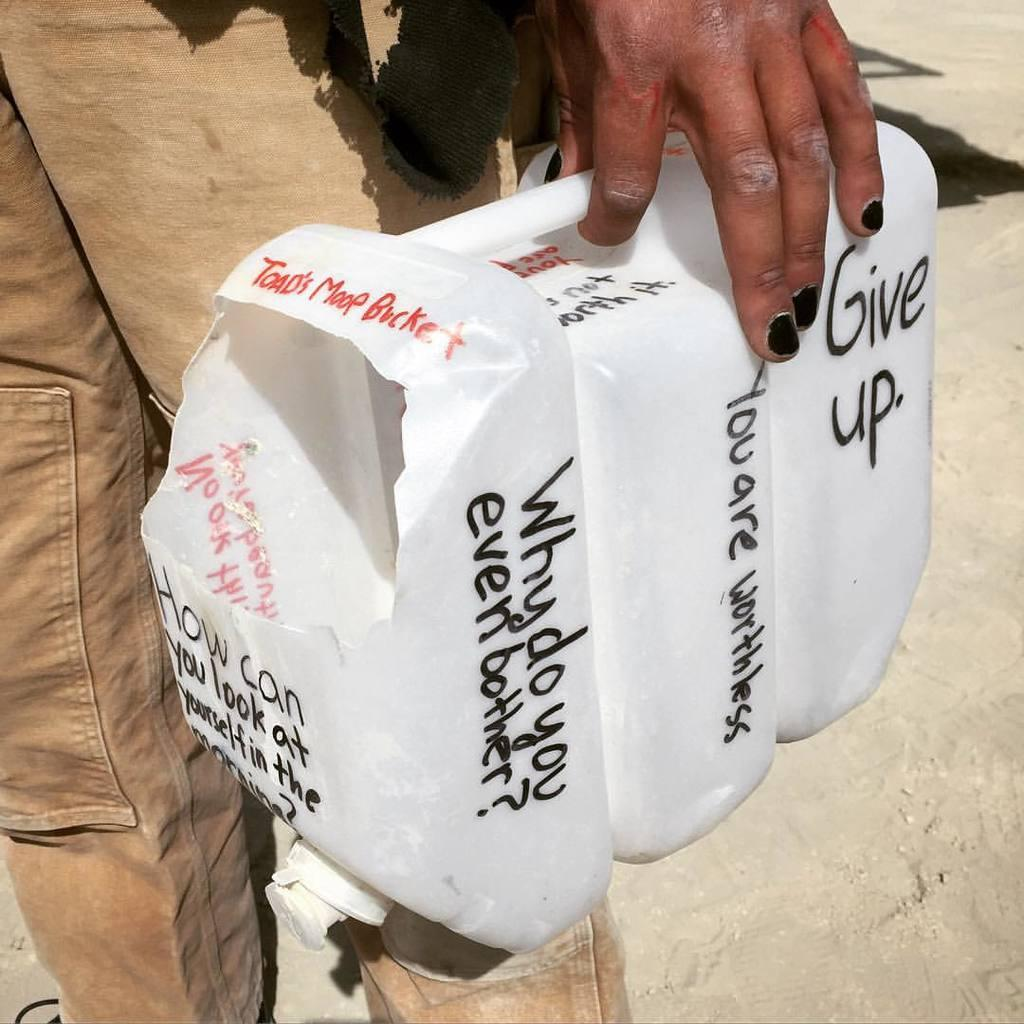What is the person in the image doing? The person is standing in the image. What object is the person holding? The person is holding a plastic container. What can be seen on the container? There is text written on the container. What type of winter clothing is the person wearing in the image? There is no mention of winter clothing or any specific season in the image, as it only shows a person holding a plastic container with text on it. 